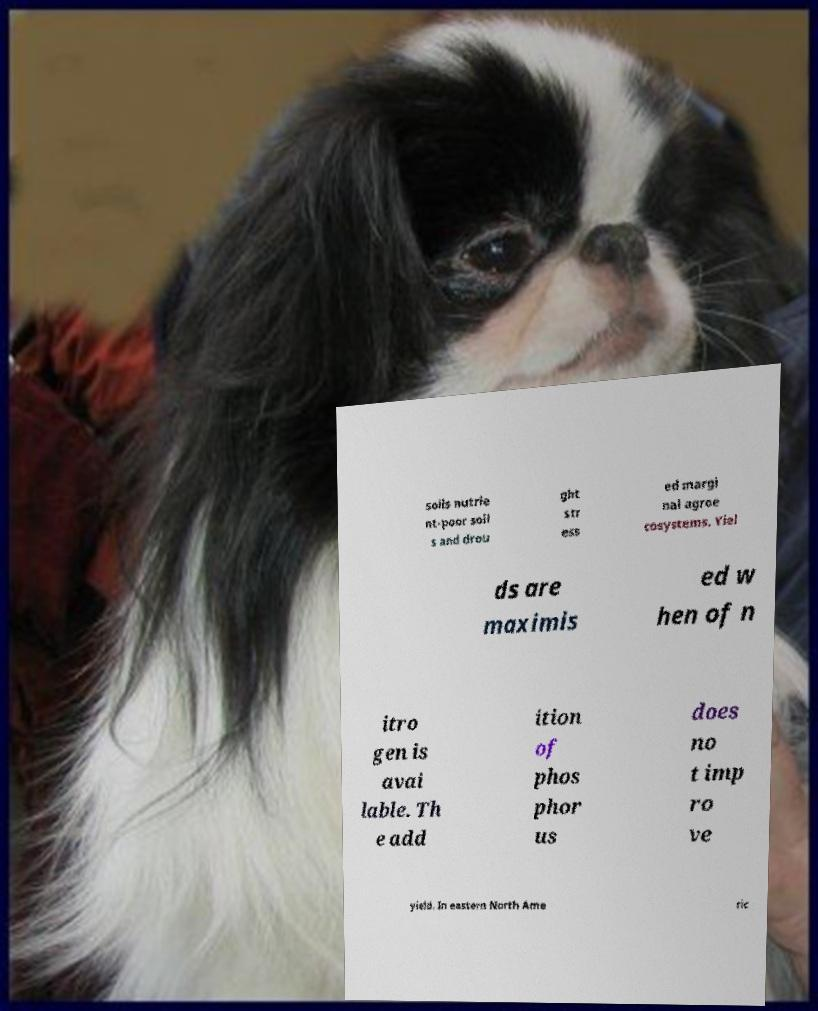Please identify and transcribe the text found in this image. soils nutrie nt-poor soil s and drou ght str ess ed margi nal agroe cosystems. Yiel ds are maximis ed w hen of n itro gen is avai lable. Th e add ition of phos phor us does no t imp ro ve yield. In eastern North Ame ric 